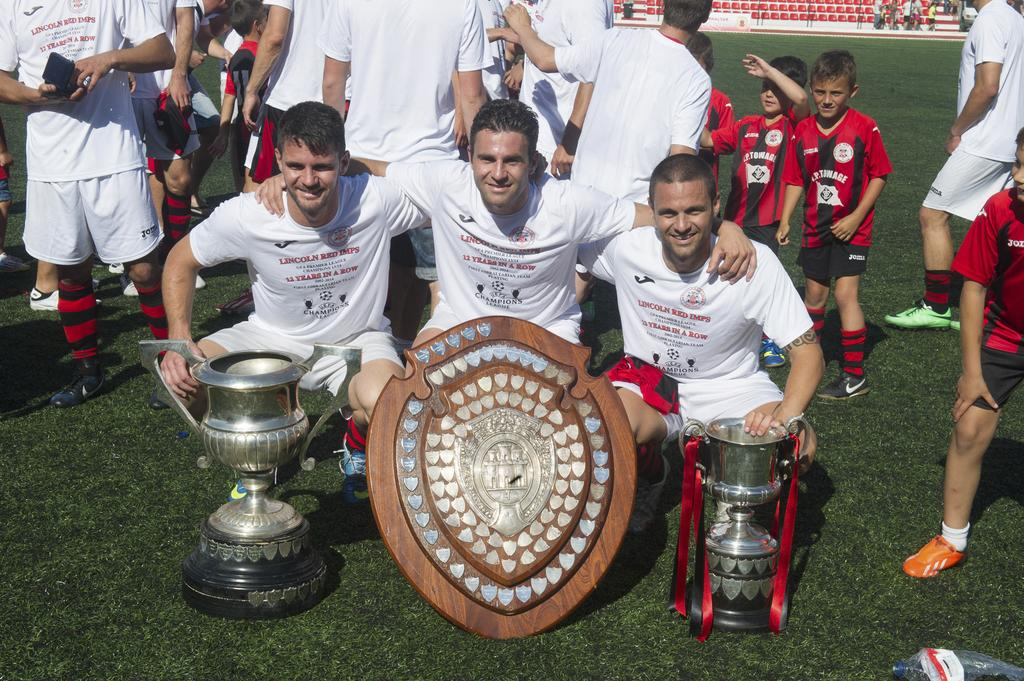What objects can be seen in the image that represent achievements? There are trophies in the image. What other object related to achievements can be seen in the image? There is a shield in the image. What are the three persons in the image doing? They are in squat positions. Can you describe the group of people in the image? There is a group of people standing in the image. What can be seen in the background of the image? There are chairs in the background of the image. What type of battle is depicted in the image? There is no battle depicted in the image; it features trophies, a shield, and people in various positions. How many brothers are present in the image? There is no mention of a brother or any family members in the image. 